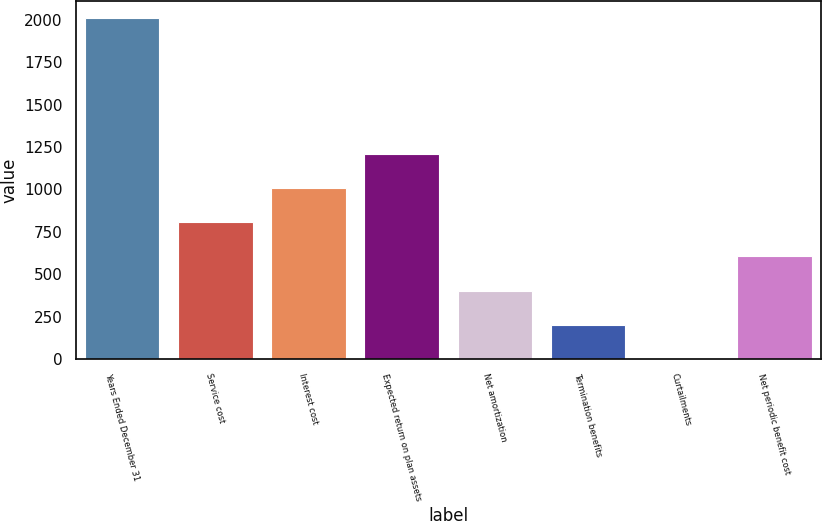<chart> <loc_0><loc_0><loc_500><loc_500><bar_chart><fcel>Years Ended December 31<fcel>Service cost<fcel>Interest cost<fcel>Expected return on plan assets<fcel>Net amortization<fcel>Termination benefits<fcel>Curtailments<fcel>Net periodic benefit cost<nl><fcel>2012<fcel>806<fcel>1007<fcel>1208<fcel>404<fcel>203<fcel>2<fcel>605<nl></chart> 